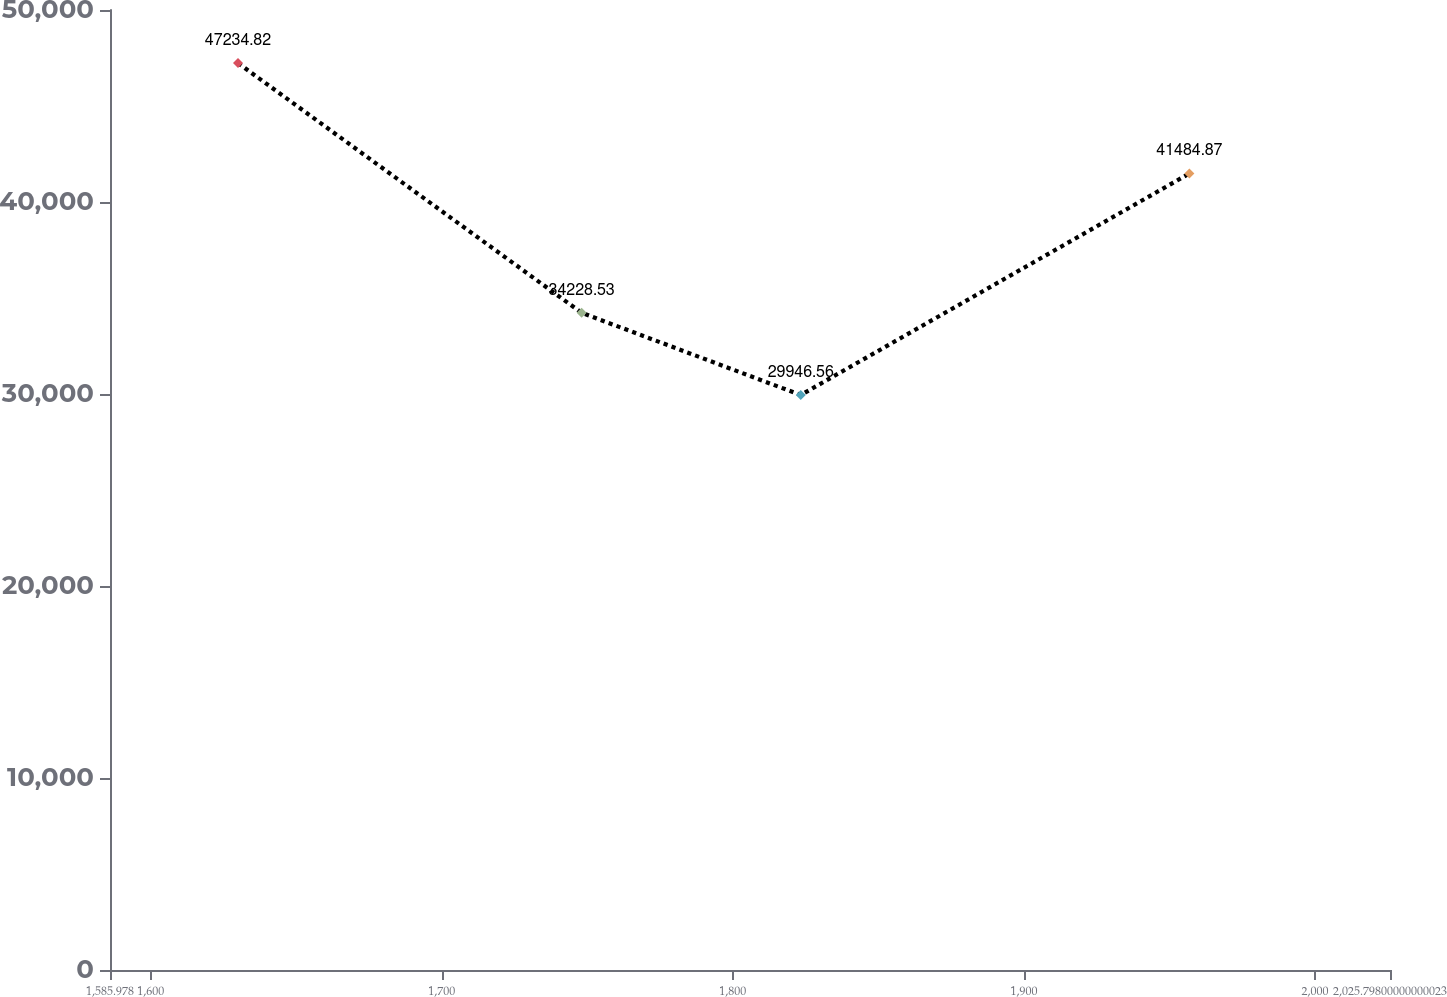<chart> <loc_0><loc_0><loc_500><loc_500><line_chart><ecel><fcel>Unnamed: 1<nl><fcel>1629.96<fcel>47234.8<nl><fcel>1748.03<fcel>34228.5<nl><fcel>1823.33<fcel>29946.6<nl><fcel>1956.86<fcel>41484.9<nl><fcel>2069.78<fcel>31675.4<nl></chart> 